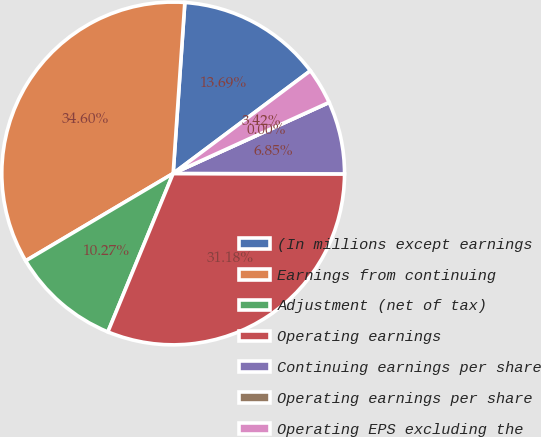Convert chart to OTSL. <chart><loc_0><loc_0><loc_500><loc_500><pie_chart><fcel>(In millions except earnings<fcel>Earnings from continuing<fcel>Adjustment (net of tax)<fcel>Operating earnings<fcel>Continuing earnings per share<fcel>Operating earnings per share<fcel>Operating EPS excluding the<nl><fcel>13.69%<fcel>34.6%<fcel>10.27%<fcel>31.18%<fcel>6.85%<fcel>0.0%<fcel>3.42%<nl></chart> 